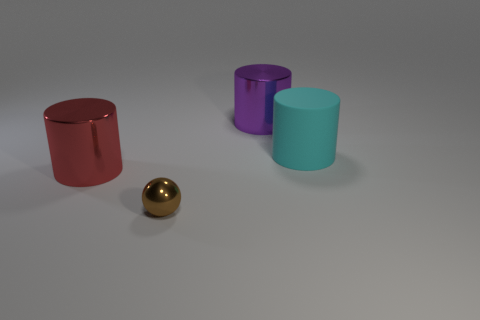How many spheres have the same size as the cyan cylinder?
Keep it short and to the point. 0. Are there fewer tiny brown metal objects that are left of the red metal cylinder than brown shiny objects in front of the small brown object?
Your answer should be very brief. No. What number of matte objects are big brown objects or small brown balls?
Keep it short and to the point. 0. The red metal thing has what shape?
Ensure brevity in your answer.  Cylinder. There is another purple cylinder that is the same size as the rubber cylinder; what material is it?
Offer a very short reply. Metal. What number of big things are either cyan metal cylinders or balls?
Your answer should be compact. 0. Are any tiny cyan metal spheres visible?
Provide a succinct answer. No. There is a purple thing that is made of the same material as the brown thing; what is its size?
Give a very brief answer. Large. Is the material of the tiny sphere the same as the big purple thing?
Provide a succinct answer. Yes. How many other objects are there of the same material as the large cyan thing?
Give a very brief answer. 0. 